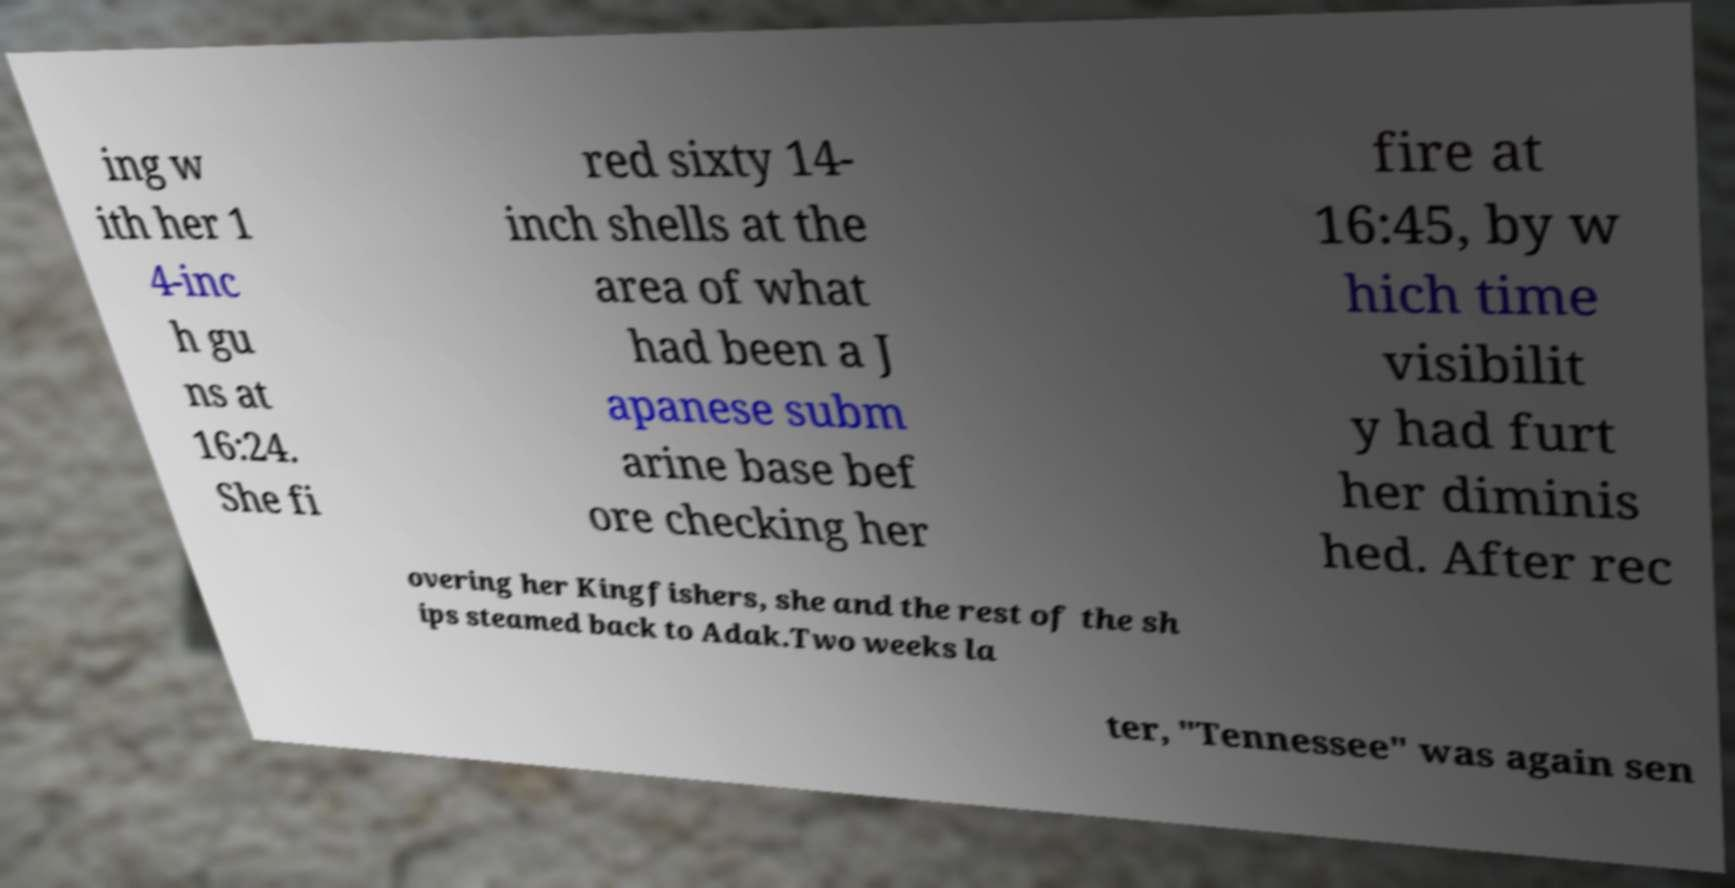For documentation purposes, I need the text within this image transcribed. Could you provide that? ing w ith her 1 4-inc h gu ns at 16:24. She fi red sixty 14- inch shells at the area of what had been a J apanese subm arine base bef ore checking her fire at 16:45, by w hich time visibilit y had furt her diminis hed. After rec overing her Kingfishers, she and the rest of the sh ips steamed back to Adak.Two weeks la ter, "Tennessee" was again sen 